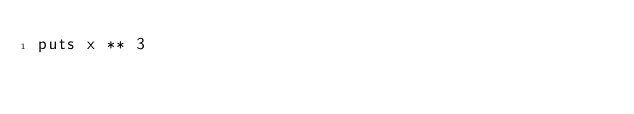Convert code to text. <code><loc_0><loc_0><loc_500><loc_500><_Ruby_>puts x ** 3</code> 